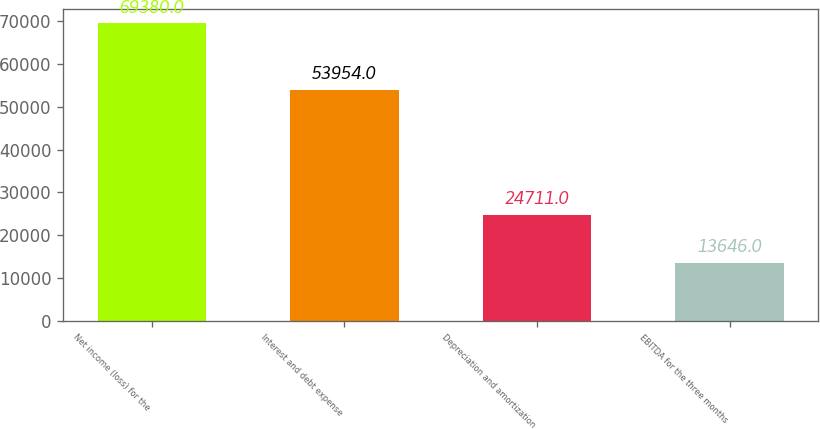Convert chart. <chart><loc_0><loc_0><loc_500><loc_500><bar_chart><fcel>Net income (loss) for the<fcel>Interest and debt expense<fcel>Depreciation and amortization<fcel>EBITDA for the three months<nl><fcel>69380<fcel>53954<fcel>24711<fcel>13646<nl></chart> 